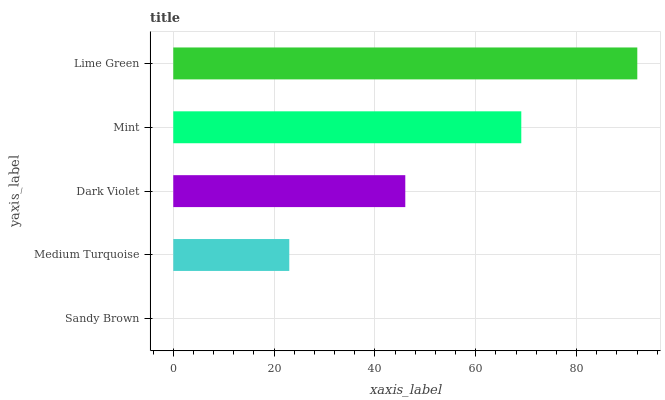Is Sandy Brown the minimum?
Answer yes or no. Yes. Is Lime Green the maximum?
Answer yes or no. Yes. Is Medium Turquoise the minimum?
Answer yes or no. No. Is Medium Turquoise the maximum?
Answer yes or no. No. Is Medium Turquoise greater than Sandy Brown?
Answer yes or no. Yes. Is Sandy Brown less than Medium Turquoise?
Answer yes or no. Yes. Is Sandy Brown greater than Medium Turquoise?
Answer yes or no. No. Is Medium Turquoise less than Sandy Brown?
Answer yes or no. No. Is Dark Violet the high median?
Answer yes or no. Yes. Is Dark Violet the low median?
Answer yes or no. Yes. Is Medium Turquoise the high median?
Answer yes or no. No. Is Mint the low median?
Answer yes or no. No. 